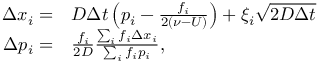<formula> <loc_0><loc_0><loc_500><loc_500>\begin{array} { r l } { \Delta x _ { i } = } & D \Delta t \left ( p _ { i } - \frac { f _ { i } } { 2 ( \nu - U ) } \right ) + \xi _ { i } \sqrt { 2 D \Delta t } } \\ { \Delta p _ { i } = } & \frac { f _ { i } } { 2 D } \frac { \sum _ { i } f _ { i } \Delta x _ { i } } { \sum _ { i } f _ { i } p _ { i } } , } \end{array}</formula> 